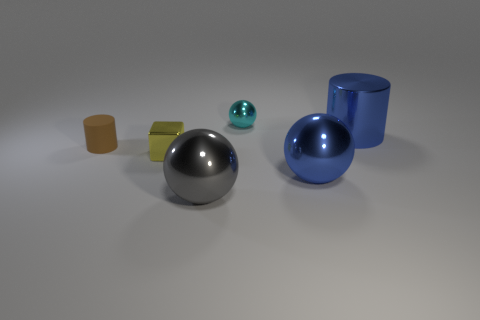Are there any other things that have the same material as the small brown thing?
Provide a succinct answer. No. What color is the ball left of the metallic ball behind the big blue shiny thing on the right side of the blue shiny ball?
Make the answer very short. Gray. Is the tiny cyan ball made of the same material as the yellow block?
Give a very brief answer. Yes. There is a rubber object; what number of gray balls are to the right of it?
Make the answer very short. 1. There is a gray object that is the same shape as the tiny cyan thing; what is its size?
Give a very brief answer. Large. How many cyan objects are big shiny balls or big metal things?
Offer a terse response. 0. There is a brown matte cylinder in front of the tiny metal sphere; how many metal objects are behind it?
Provide a succinct answer. 2. How many other objects are the same shape as the tiny brown rubber thing?
Offer a terse response. 1. What material is the large sphere that is the same color as the big metal cylinder?
Offer a very short reply. Metal. What number of tiny cubes have the same color as the small metallic sphere?
Provide a succinct answer. 0. 